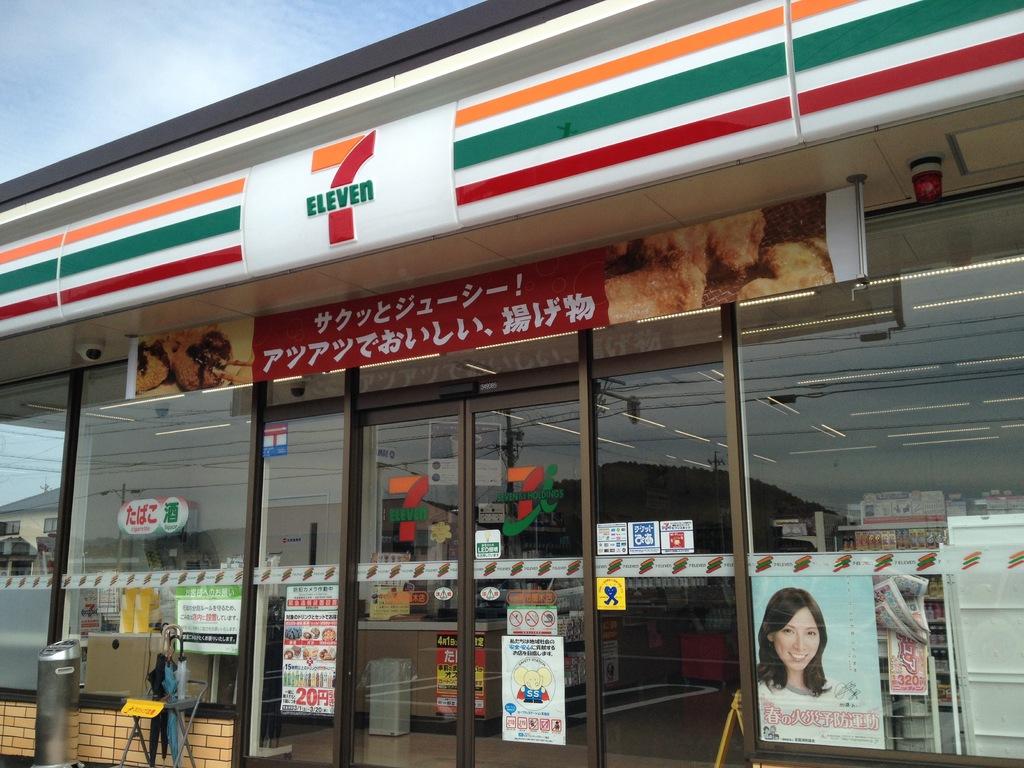What is the name of this store?
Offer a terse response. 7 eleven. 